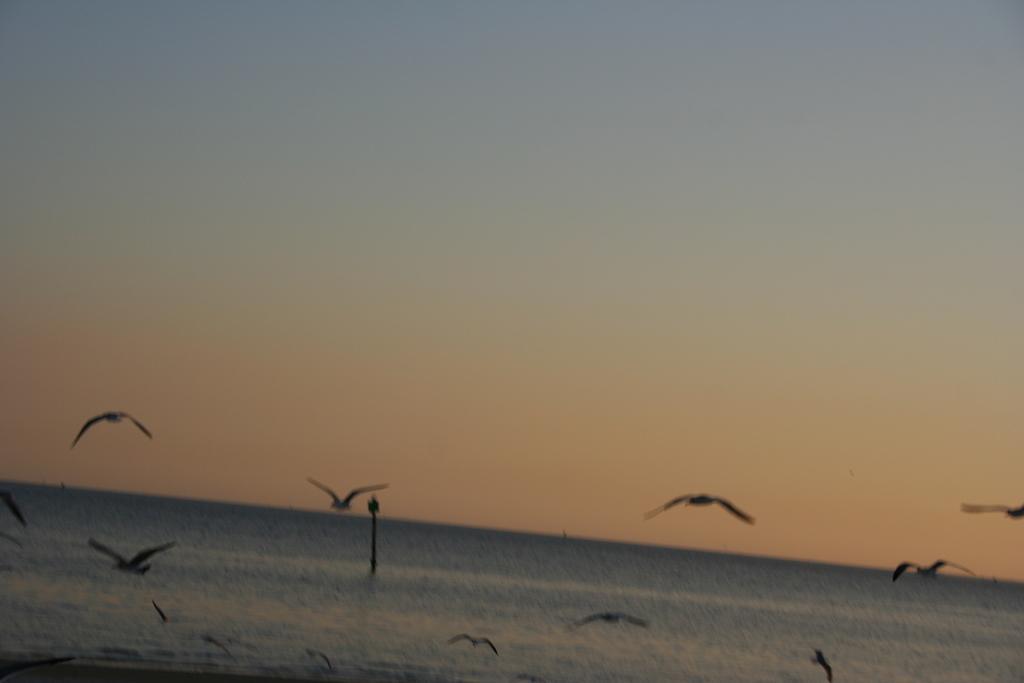Can you describe this image briefly? At the bottom of the picture, we see water and this water might be in the sea. We see the birds are flying. In the middle of the picture, it looks like a pole. At the top, we see the sky. 